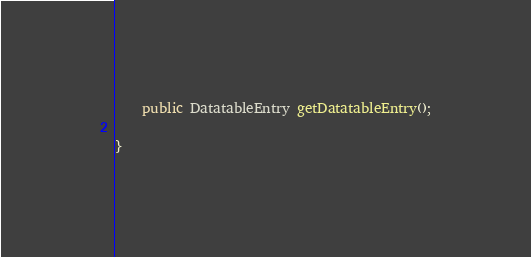<code> <loc_0><loc_0><loc_500><loc_500><_Java_>	public DatatableEntry getDatatableEntry();

}
</code> 